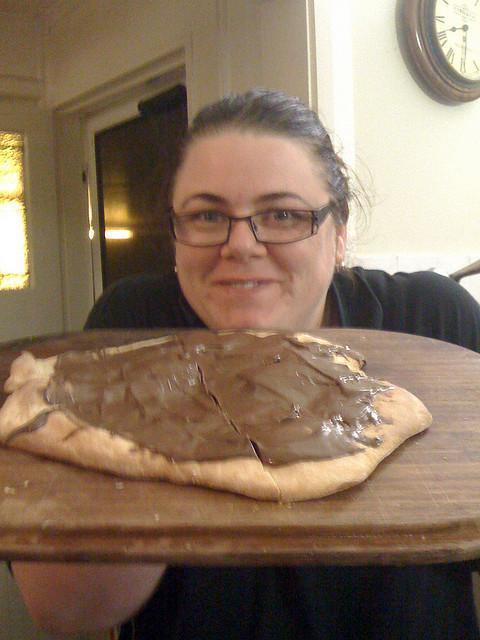How many pizzas are there?
Give a very brief answer. 1. 